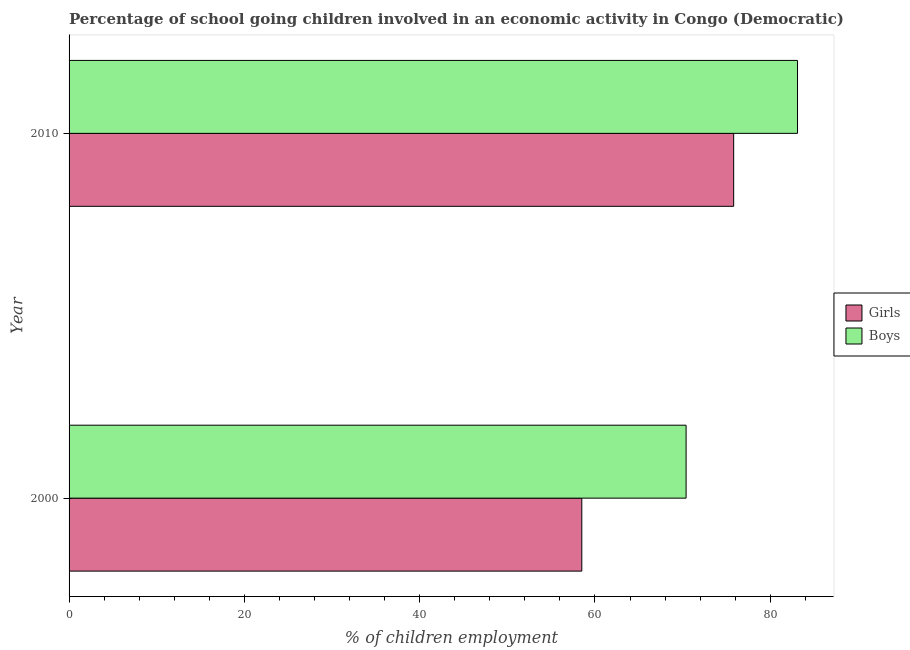Are the number of bars per tick equal to the number of legend labels?
Your answer should be very brief. Yes. Are the number of bars on each tick of the Y-axis equal?
Your response must be concise. Yes. How many bars are there on the 1st tick from the top?
Offer a very short reply. 2. What is the percentage of school going boys in 2010?
Your answer should be compact. 83.11. Across all years, what is the maximum percentage of school going boys?
Provide a succinct answer. 83.11. Across all years, what is the minimum percentage of school going boys?
Give a very brief answer. 70.4. In which year was the percentage of school going girls maximum?
Ensure brevity in your answer.  2010. What is the total percentage of school going girls in the graph?
Provide a succinct answer. 134.33. What is the difference between the percentage of school going girls in 2000 and that in 2010?
Provide a short and direct response. -17.33. What is the difference between the percentage of school going girls in 2010 and the percentage of school going boys in 2000?
Provide a short and direct response. 5.43. What is the average percentage of school going girls per year?
Provide a short and direct response. 67.16. In the year 2010, what is the difference between the percentage of school going girls and percentage of school going boys?
Offer a very short reply. -7.29. In how many years, is the percentage of school going boys greater than 16 %?
Your response must be concise. 2. What is the ratio of the percentage of school going girls in 2000 to that in 2010?
Make the answer very short. 0.77. In how many years, is the percentage of school going girls greater than the average percentage of school going girls taken over all years?
Keep it short and to the point. 1. What does the 2nd bar from the top in 2000 represents?
Give a very brief answer. Girls. What does the 2nd bar from the bottom in 2010 represents?
Make the answer very short. Boys. How many years are there in the graph?
Provide a short and direct response. 2. Does the graph contain any zero values?
Offer a terse response. No. What is the title of the graph?
Make the answer very short. Percentage of school going children involved in an economic activity in Congo (Democratic). Does "Residents" appear as one of the legend labels in the graph?
Your answer should be compact. No. What is the label or title of the X-axis?
Offer a very short reply. % of children employment. What is the label or title of the Y-axis?
Offer a terse response. Year. What is the % of children employment in Girls in 2000?
Make the answer very short. 58.5. What is the % of children employment of Boys in 2000?
Your answer should be compact. 70.4. What is the % of children employment of Girls in 2010?
Make the answer very short. 75.83. What is the % of children employment in Boys in 2010?
Offer a terse response. 83.11. Across all years, what is the maximum % of children employment of Girls?
Offer a very short reply. 75.83. Across all years, what is the maximum % of children employment of Boys?
Make the answer very short. 83.11. Across all years, what is the minimum % of children employment in Girls?
Your response must be concise. 58.5. Across all years, what is the minimum % of children employment in Boys?
Give a very brief answer. 70.4. What is the total % of children employment of Girls in the graph?
Give a very brief answer. 134.33. What is the total % of children employment in Boys in the graph?
Offer a terse response. 153.51. What is the difference between the % of children employment of Girls in 2000 and that in 2010?
Your answer should be compact. -17.33. What is the difference between the % of children employment in Boys in 2000 and that in 2010?
Make the answer very short. -12.71. What is the difference between the % of children employment of Girls in 2000 and the % of children employment of Boys in 2010?
Provide a succinct answer. -24.61. What is the average % of children employment of Girls per year?
Give a very brief answer. 67.16. What is the average % of children employment of Boys per year?
Keep it short and to the point. 76.76. In the year 2010, what is the difference between the % of children employment in Girls and % of children employment in Boys?
Your answer should be compact. -7.29. What is the ratio of the % of children employment of Girls in 2000 to that in 2010?
Your response must be concise. 0.77. What is the ratio of the % of children employment in Boys in 2000 to that in 2010?
Your response must be concise. 0.85. What is the difference between the highest and the second highest % of children employment of Girls?
Ensure brevity in your answer.  17.33. What is the difference between the highest and the second highest % of children employment of Boys?
Make the answer very short. 12.71. What is the difference between the highest and the lowest % of children employment of Girls?
Offer a terse response. 17.33. What is the difference between the highest and the lowest % of children employment of Boys?
Provide a succinct answer. 12.71. 